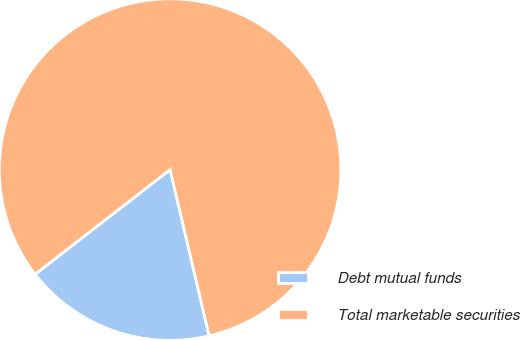<chart> <loc_0><loc_0><loc_500><loc_500><pie_chart><fcel>Debt mutual funds<fcel>Total marketable securities<nl><fcel>18.18%<fcel>81.82%<nl></chart> 